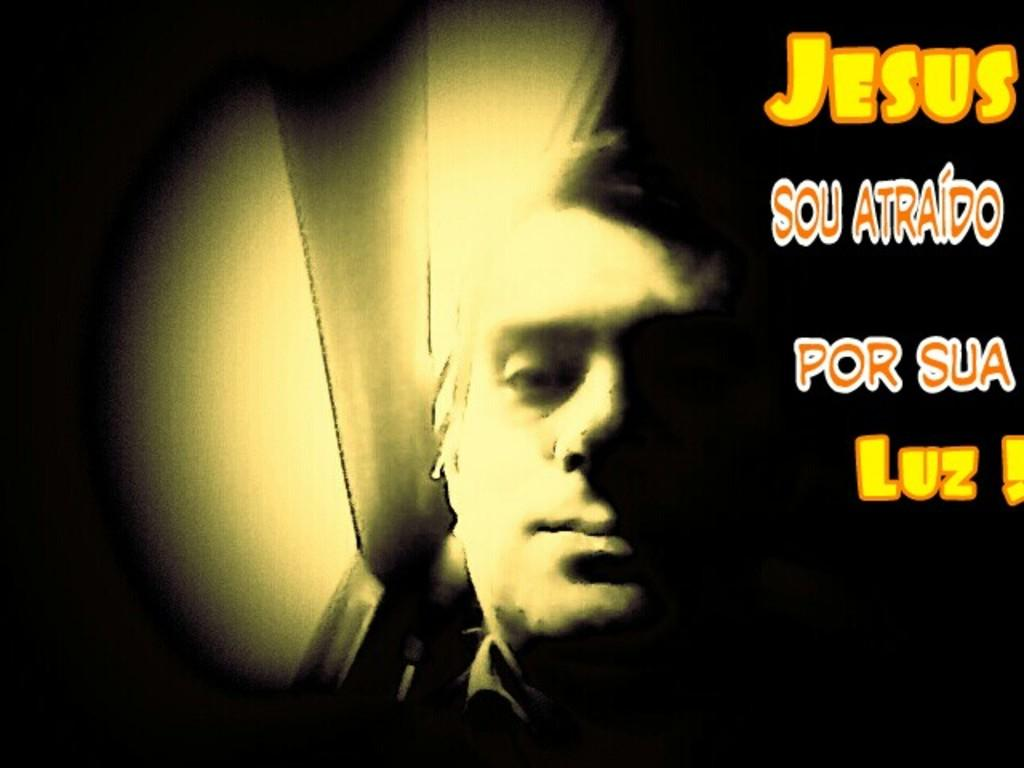What is present in the image? There is a person and objects in the image. Can you describe the person in the image? Unfortunately, the provided facts do not give any details about the person's appearance or actions. What can be seen on the right side of the image? There is text on the right side of the image. What type of straw is being used in the fight scene in the image? There is no fight scene or straw present in the image. 